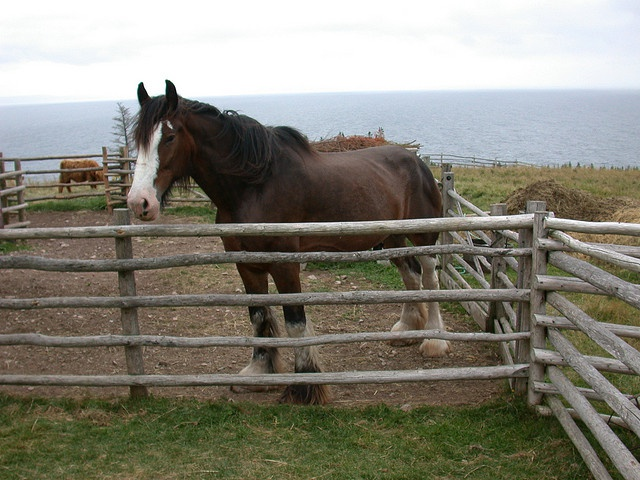Describe the objects in this image and their specific colors. I can see horse in white, black, gray, and darkgray tones and cow in white, maroon, black, and gray tones in this image. 